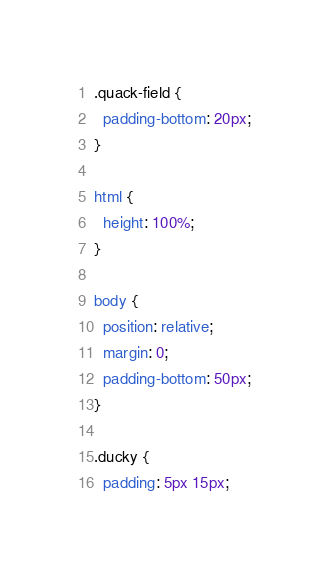<code> <loc_0><loc_0><loc_500><loc_500><_CSS_>.quack-field {
  padding-bottom: 20px;
}

html {
  height: 100%;
}

body {
  position: relative;
  margin: 0;
  padding-bottom: 50px;
}

.ducky {
  padding: 5px 15px;</code> 